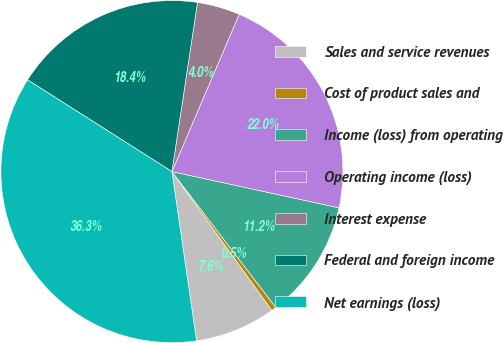Convert chart to OTSL. <chart><loc_0><loc_0><loc_500><loc_500><pie_chart><fcel>Sales and service revenues<fcel>Cost of product sales and<fcel>Income (loss) from operating<fcel>Operating income (loss)<fcel>Interest expense<fcel>Federal and foreign income<fcel>Net earnings (loss)<nl><fcel>7.63%<fcel>0.46%<fcel>11.21%<fcel>21.97%<fcel>4.04%<fcel>18.38%<fcel>36.31%<nl></chart> 